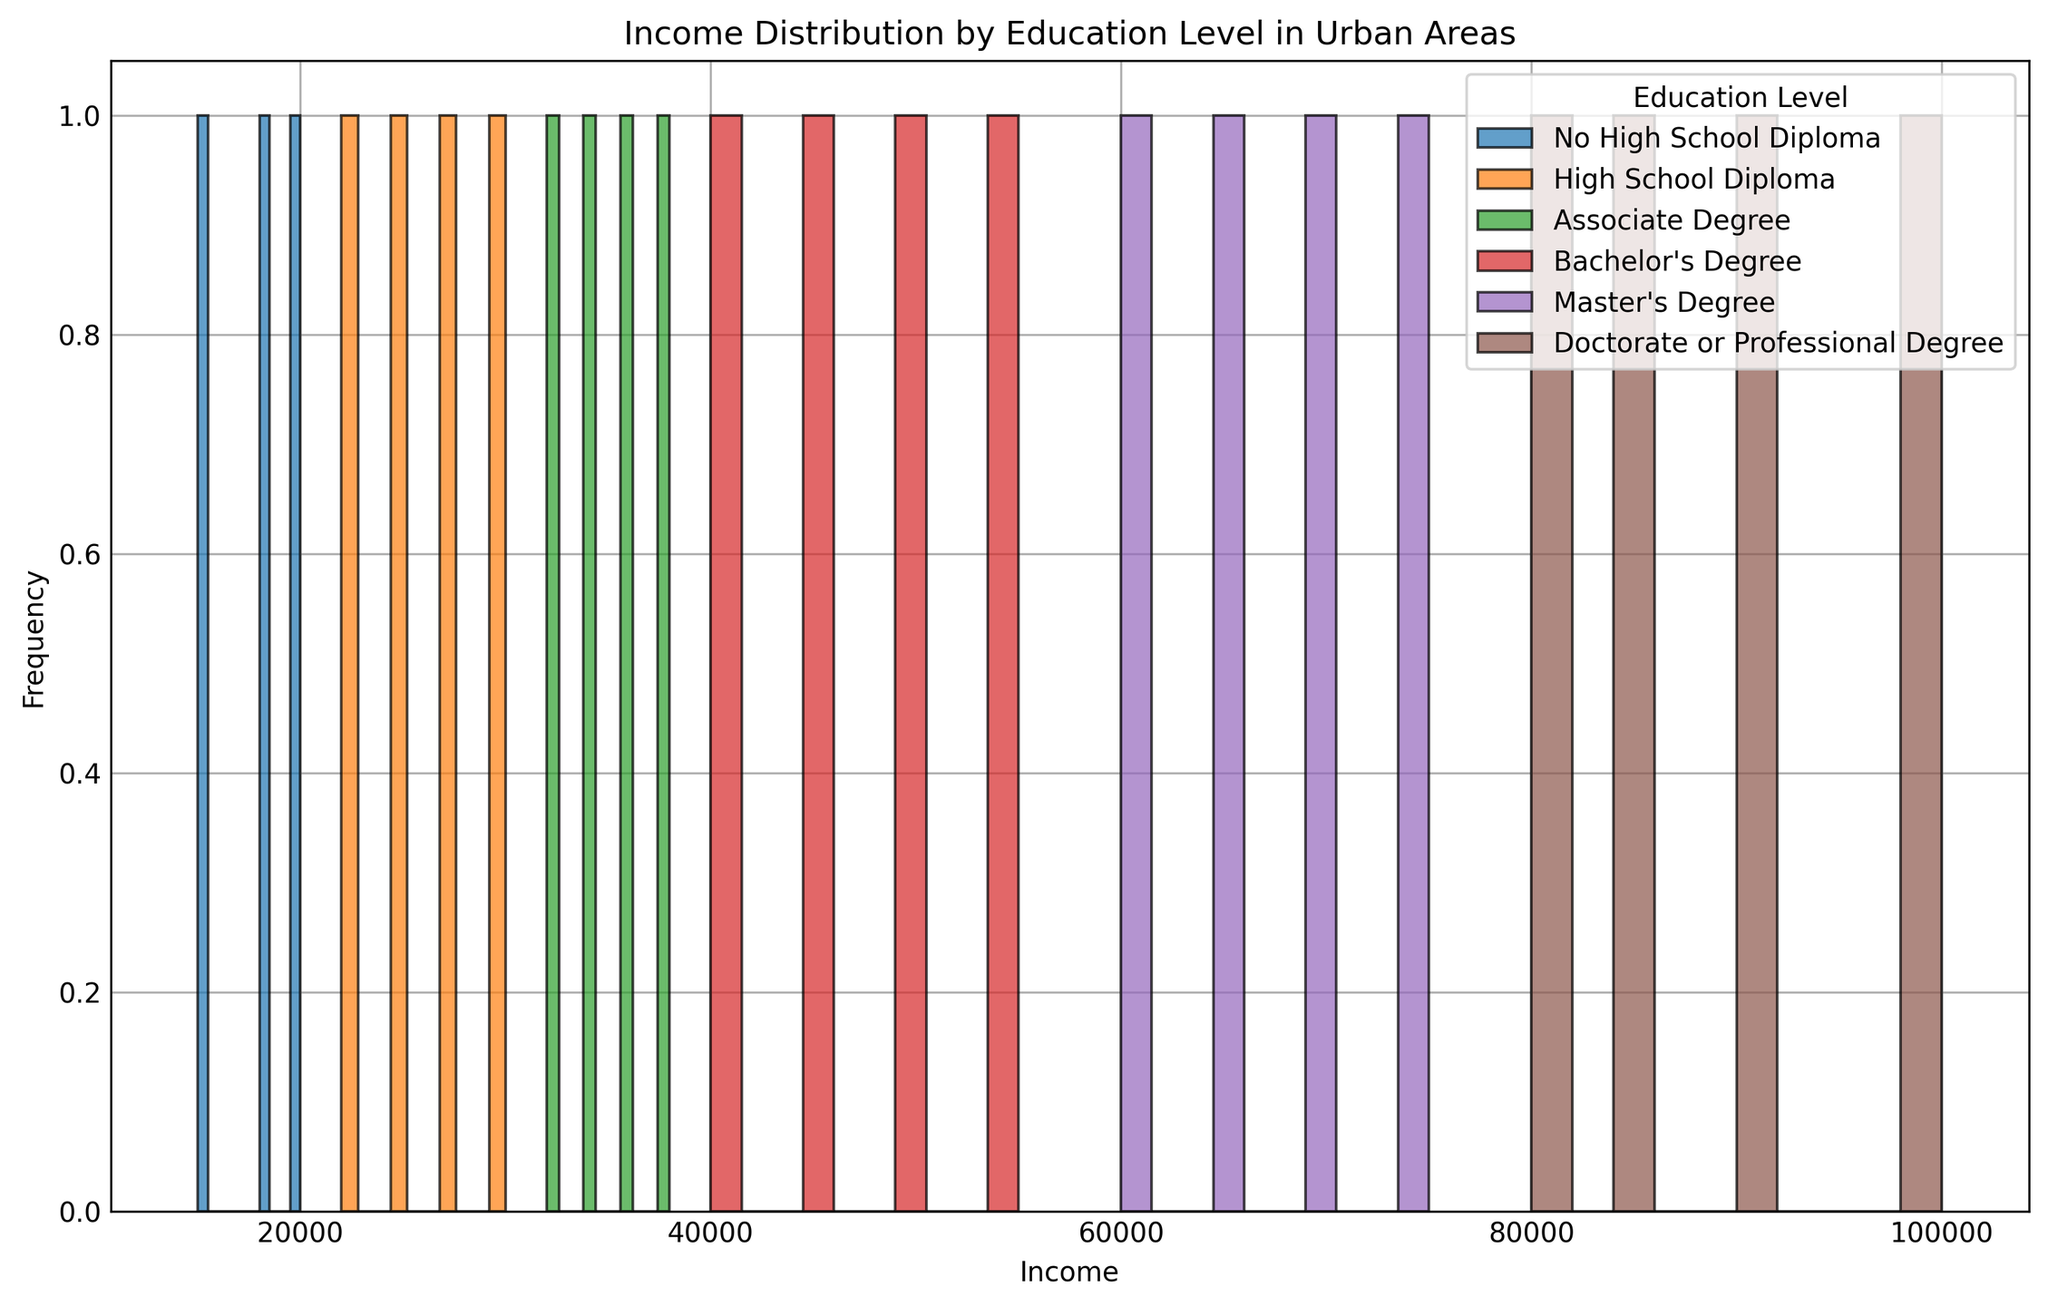What is the income range covered by the histogram? The histogram bins incomes and the x-axis reflects this. It ranges from below $10,000 to $100,000 as seen from the lowest and highest labeled bars.
Answer: $<10,000$ to $100,000$ Which education level shows the widest range of income in the histogram? To determine the widest range, observe the horizontal span of each education level's distribution. Doctorate or Professional Degree spans from $80,000 to $100,000, indicating a range of $20,000, whereas others span less.
Answer: Doctorate or Professional Degree For which education level is the median income around $30,000? The median income is around the central value. For High School Diploma, the middle values of bins generally cluster near $30,000.
Answer: High School Diploma Which education level has the highest frequency count for incomes below $20,000? Examine the height of the bars in the $<20,000$ range. The tallest bars in this range belong to the No High School Diploma group.
Answer: No High School Diploma How does the median income of those with Bachelor's Degrees compare to those with Associate Degrees? Look for the middle income values of both groups in the histogram. Bachelor's Degree bars center around $45,000, higher than Associate Degree's center around $35,000.
Answer: Bachelor's Degree median is higher Which education level appears to have the most evenly distributed income range? An even distribution shows similar heights across income bins. The Master's Degree group appears to show more evenly spread bars across its range from $60,000 to $75,000.
Answer: Master's Degree What is the most common income range for people with a Master's degree? The tallest bar in the Master's Degree section indicates the most common income range, between $60,000 and $65,000.
Answer: $60,000 to $65,000 Who earns more on average, someone with an Associate Degree or someone with a Bachelor's Degree? The average income correlates with the frequency spread over income ranges. Bachelor's Degree is spread across higher income ranges ($40,000 to $55,000) than Associate Degree ($32,000 to $38,000).
Answer: Bachelor's Degree 